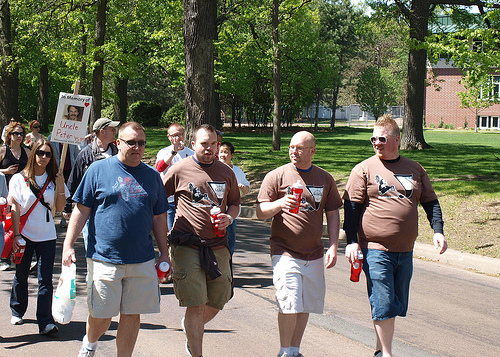<image>
Is the tree in the man? No. The tree is not contained within the man. These objects have a different spatial relationship. 